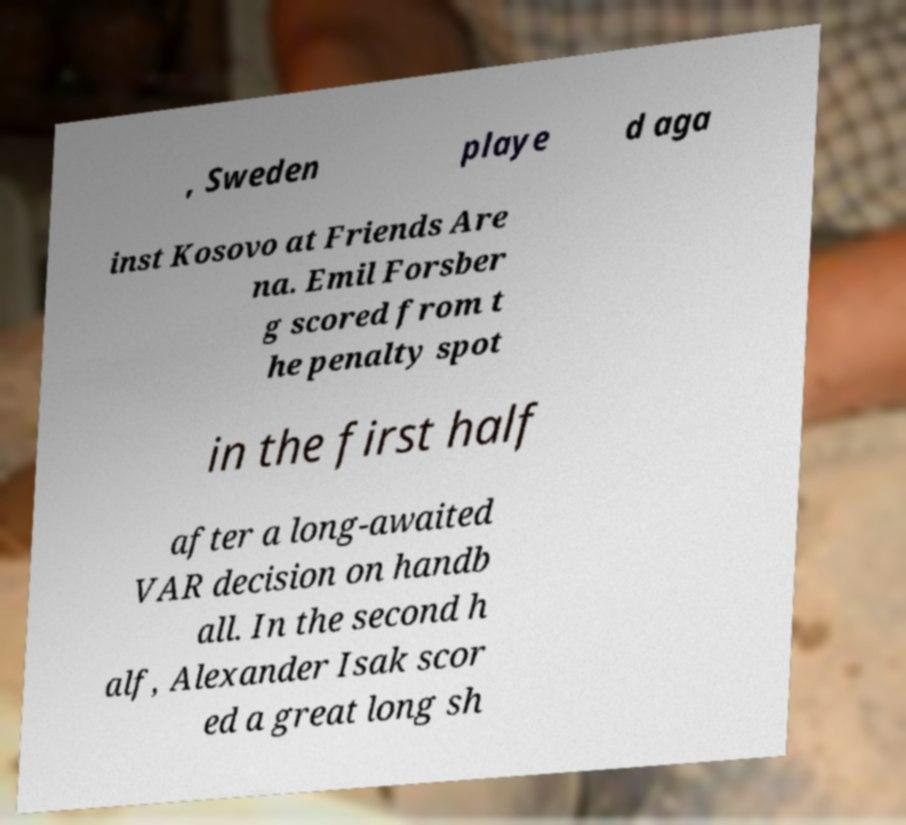There's text embedded in this image that I need extracted. Can you transcribe it verbatim? , Sweden playe d aga inst Kosovo at Friends Are na. Emil Forsber g scored from t he penalty spot in the first half after a long-awaited VAR decision on handb all. In the second h alf, Alexander Isak scor ed a great long sh 